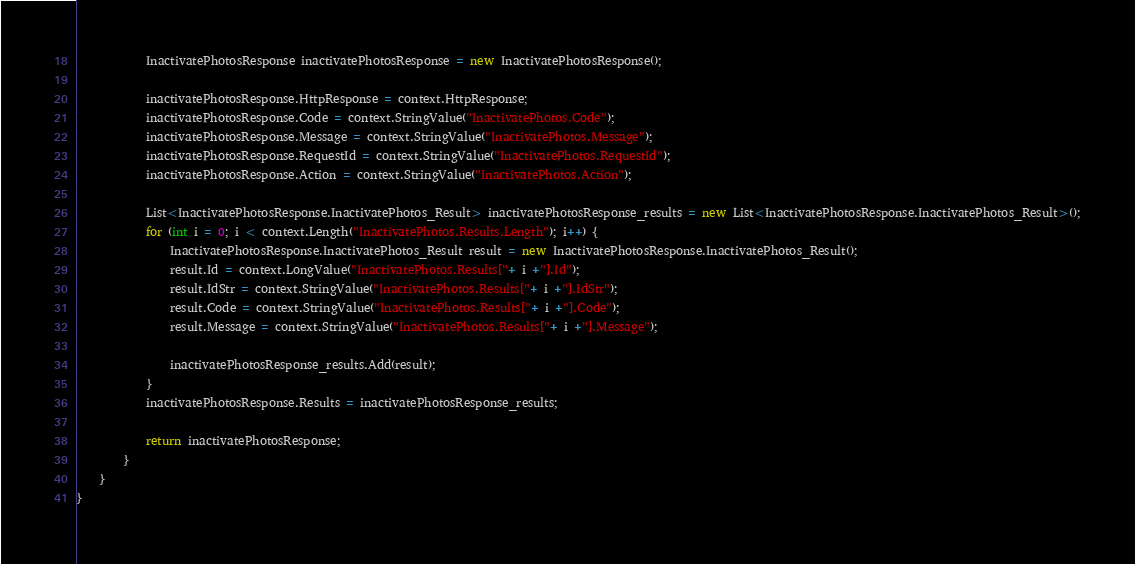Convert code to text. <code><loc_0><loc_0><loc_500><loc_500><_C#_>			InactivatePhotosResponse inactivatePhotosResponse = new InactivatePhotosResponse();

			inactivatePhotosResponse.HttpResponse = context.HttpResponse;
			inactivatePhotosResponse.Code = context.StringValue("InactivatePhotos.Code");
			inactivatePhotosResponse.Message = context.StringValue("InactivatePhotos.Message");
			inactivatePhotosResponse.RequestId = context.StringValue("InactivatePhotos.RequestId");
			inactivatePhotosResponse.Action = context.StringValue("InactivatePhotos.Action");

			List<InactivatePhotosResponse.InactivatePhotos_Result> inactivatePhotosResponse_results = new List<InactivatePhotosResponse.InactivatePhotos_Result>();
			for (int i = 0; i < context.Length("InactivatePhotos.Results.Length"); i++) {
				InactivatePhotosResponse.InactivatePhotos_Result result = new InactivatePhotosResponse.InactivatePhotos_Result();
				result.Id = context.LongValue("InactivatePhotos.Results["+ i +"].Id");
				result.IdStr = context.StringValue("InactivatePhotos.Results["+ i +"].IdStr");
				result.Code = context.StringValue("InactivatePhotos.Results["+ i +"].Code");
				result.Message = context.StringValue("InactivatePhotos.Results["+ i +"].Message");

				inactivatePhotosResponse_results.Add(result);
			}
			inactivatePhotosResponse.Results = inactivatePhotosResponse_results;
        
			return inactivatePhotosResponse;
        }
    }
}</code> 